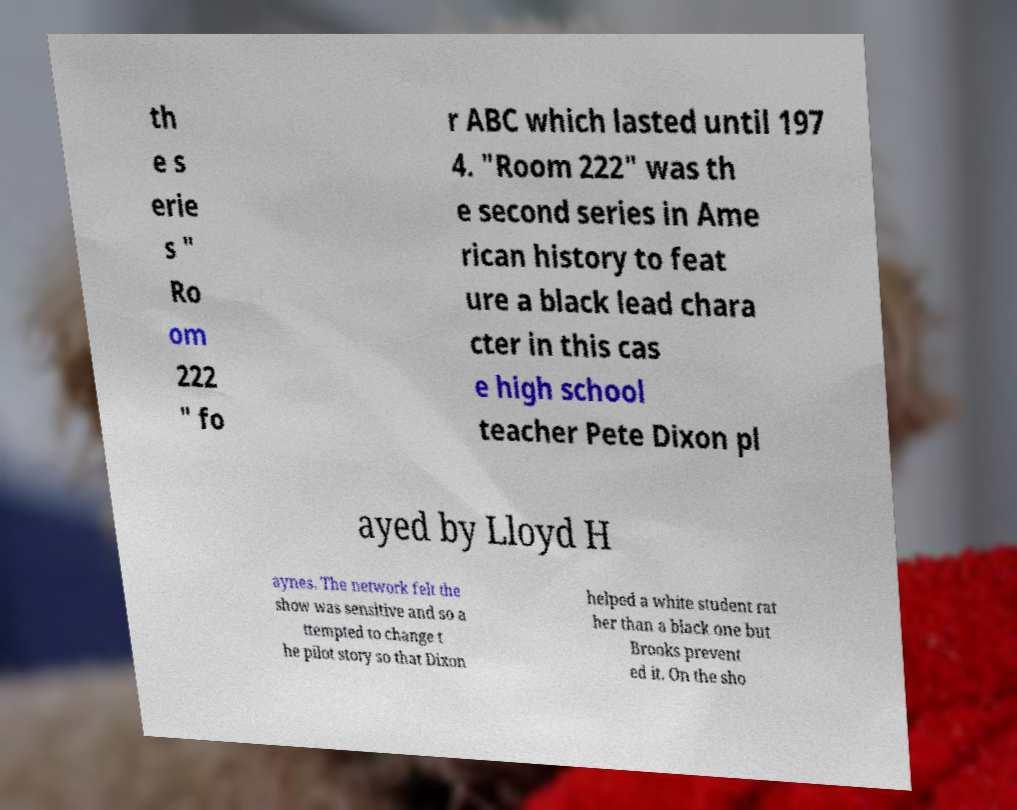There's text embedded in this image that I need extracted. Can you transcribe it verbatim? th e s erie s " Ro om 222 " fo r ABC which lasted until 197 4. "Room 222" was th e second series in Ame rican history to feat ure a black lead chara cter in this cas e high school teacher Pete Dixon pl ayed by Lloyd H aynes. The network felt the show was sensitive and so a ttempted to change t he pilot story so that Dixon helped a white student rat her than a black one but Brooks prevent ed it. On the sho 